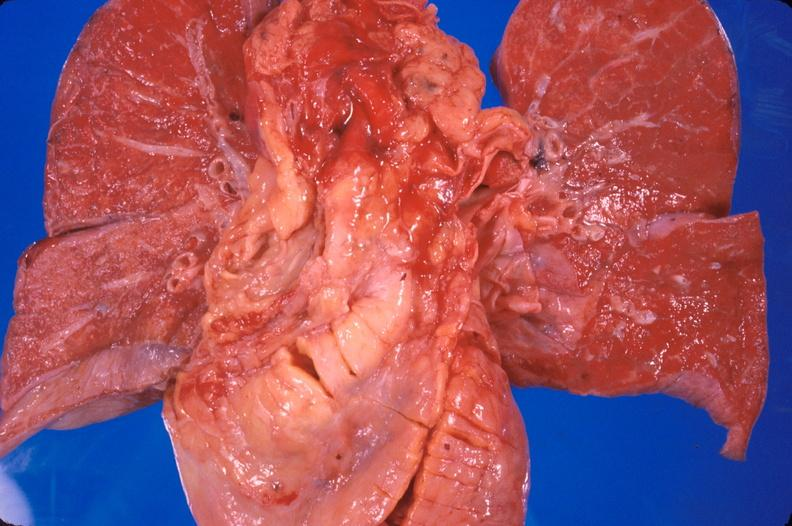does beckwith-wiedemann syndrome show heart transplant, 2 years post surgery?
Answer the question using a single word or phrase. No 